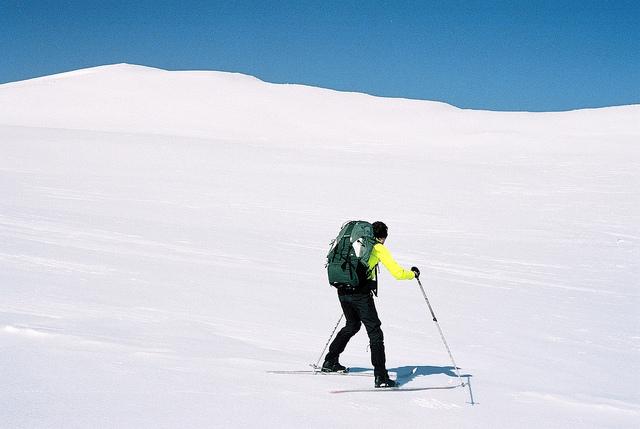What color is the person's backpack?
Write a very short answer. Green. What is on the ground?
Write a very short answer. Snow. Is skiing satisfying for this man?
Be succinct. Yes. 